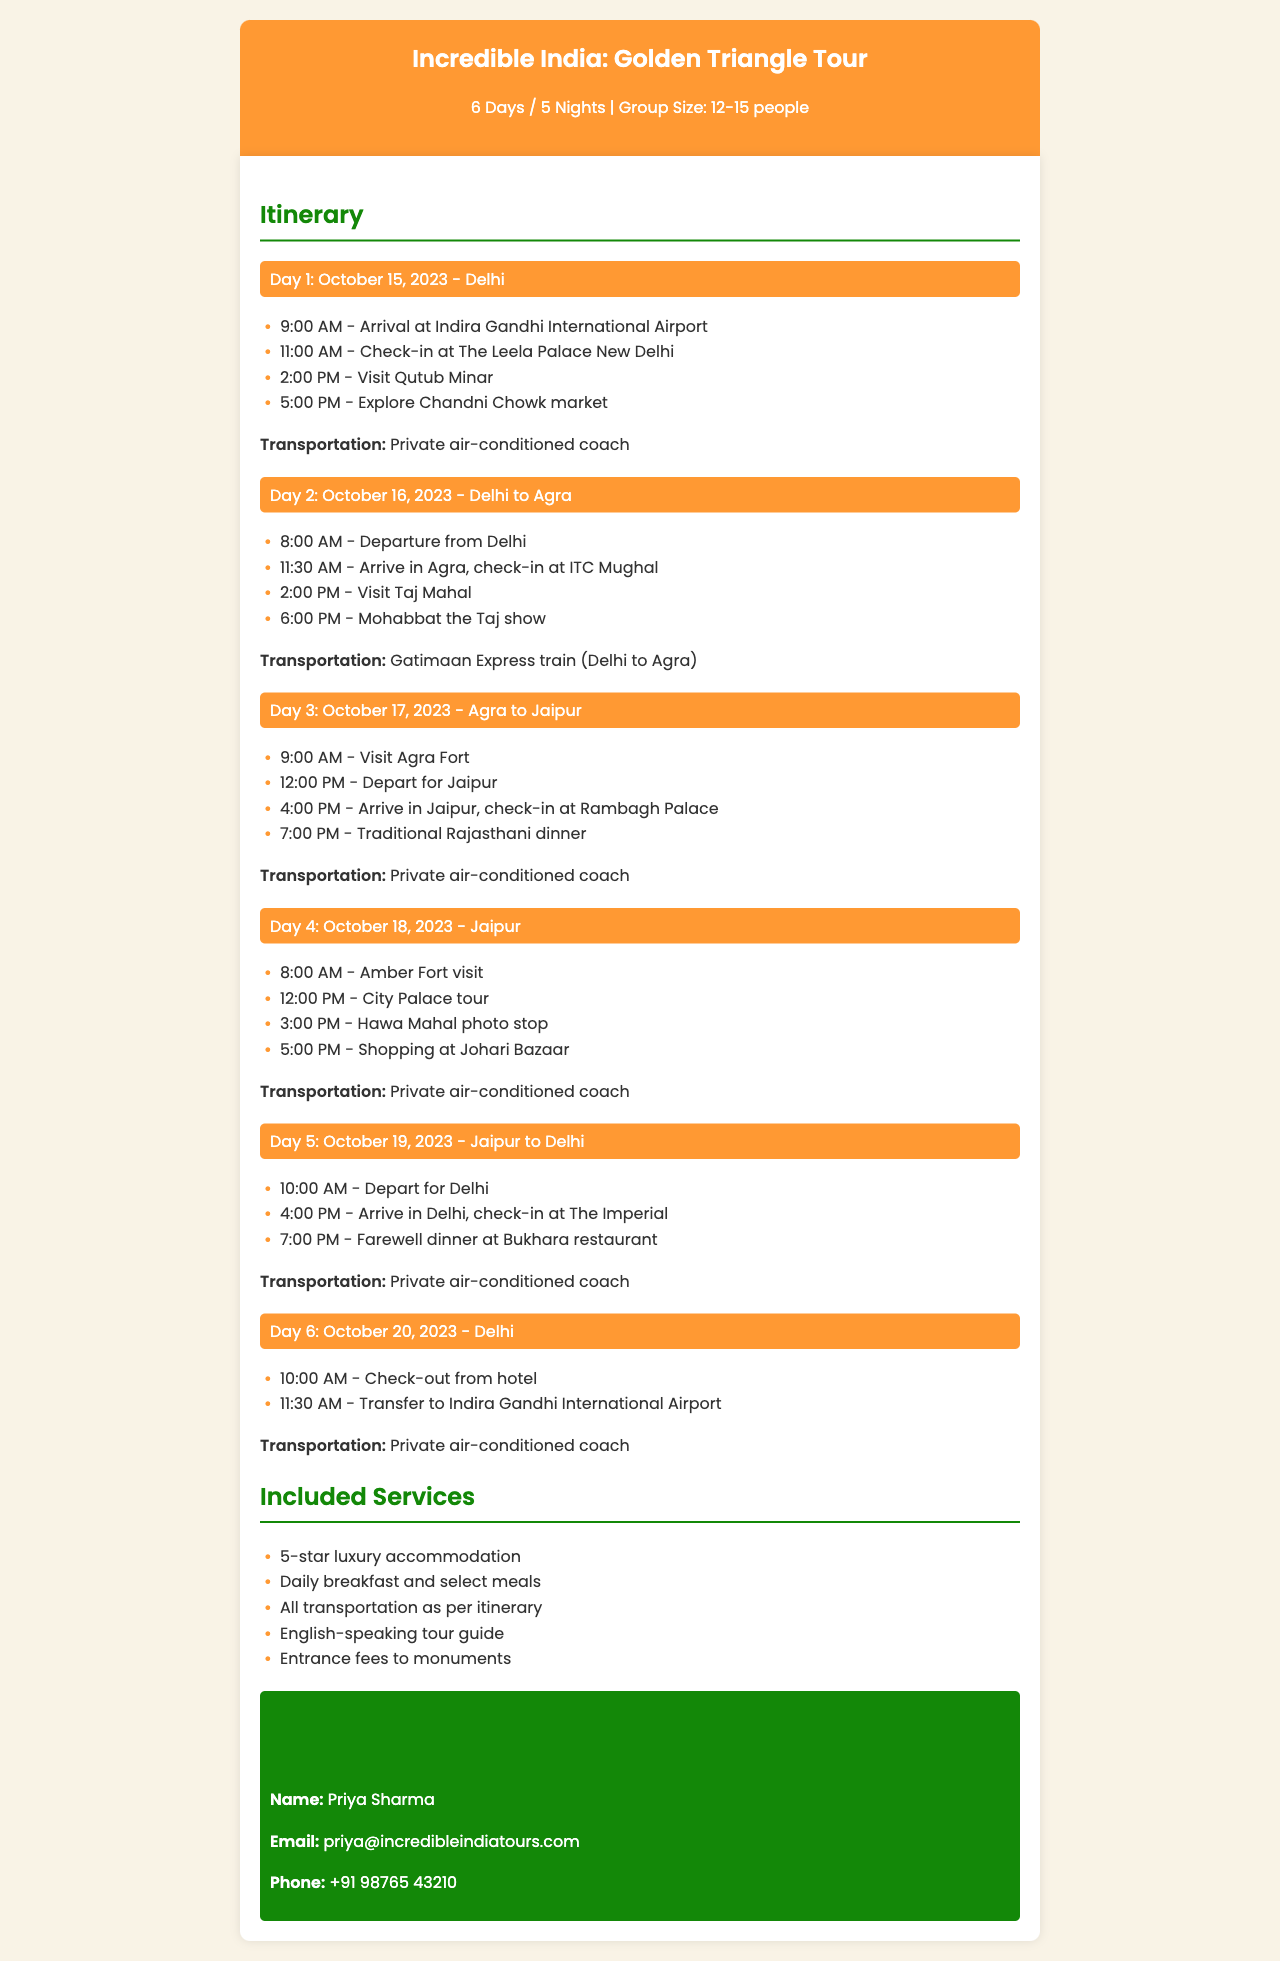What is the duration of the tour? The duration of the tour is specified in the title as 6 Days / 5 Nights.
Answer: 6 Days / 5 Nights Who is the contact person for the tour? The contact information section provides the name of the contact person, which is listed under "Contact Information".
Answer: Priya Sharma What is the accommodation in Agra? The accommodation details for Agra are listed in the itinerary under Day 2.
Answer: ITC Mughal When does the group depart for Jaipur? The departure for Jaipur is scheduled in the itinerary on Day 3.
Answer: 12:00 PM What activity is scheduled on Day 4 at 3:00 PM? The itinerary specifies the activity scheduled at that time under Day 4.
Answer: Hawa Mahal photo stop How many people are in the group size? The group size is mentioned in the introduction, which states the size of the group.
Answer: 12-15 people What mode of transportation is used from Delhi to Agra? The transportation details are provided in the itinerary for Day 2.
Answer: Gatimaan Express train What time does breakfast start each day? Breakfast is included daily, but the specific timing is not mentioned in the document.
Answer: Not specified 